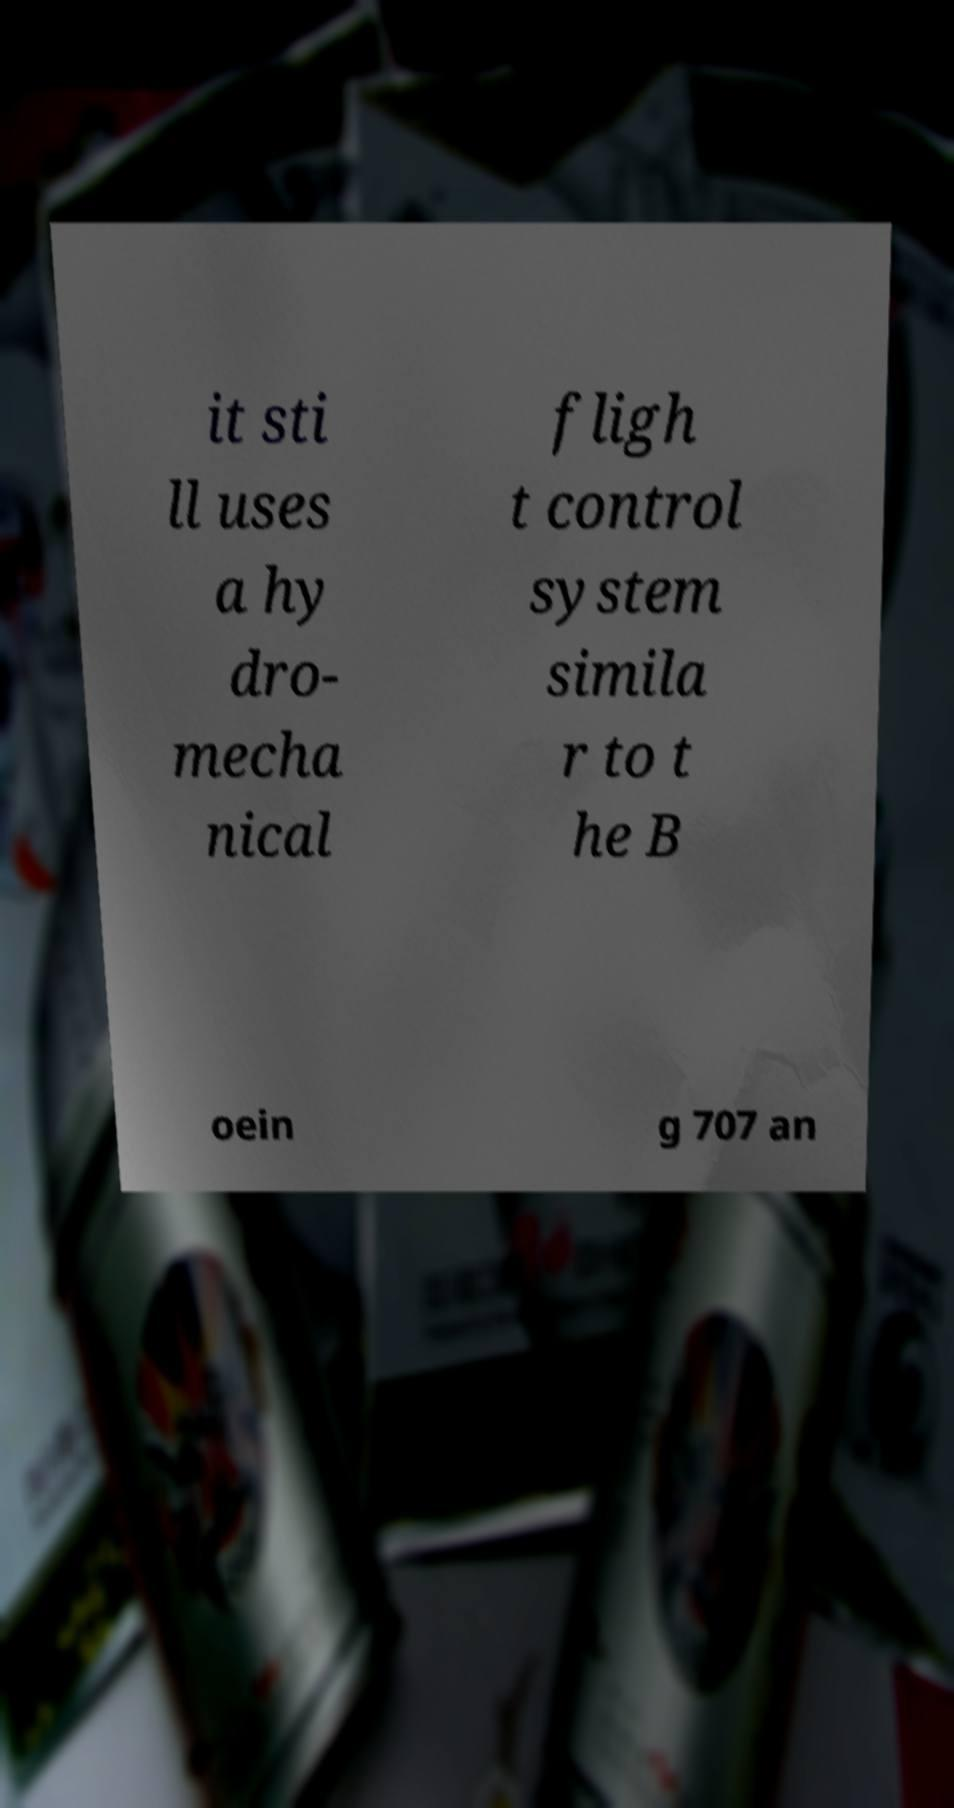There's text embedded in this image that I need extracted. Can you transcribe it verbatim? it sti ll uses a hy dro- mecha nical fligh t control system simila r to t he B oein g 707 an 